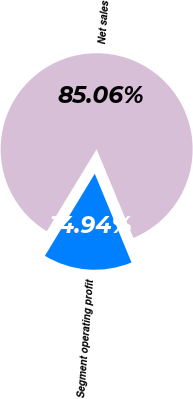<chart> <loc_0><loc_0><loc_500><loc_500><pie_chart><fcel>Net sales<fcel>Segment operating profit<nl><fcel>85.06%<fcel>14.94%<nl></chart> 